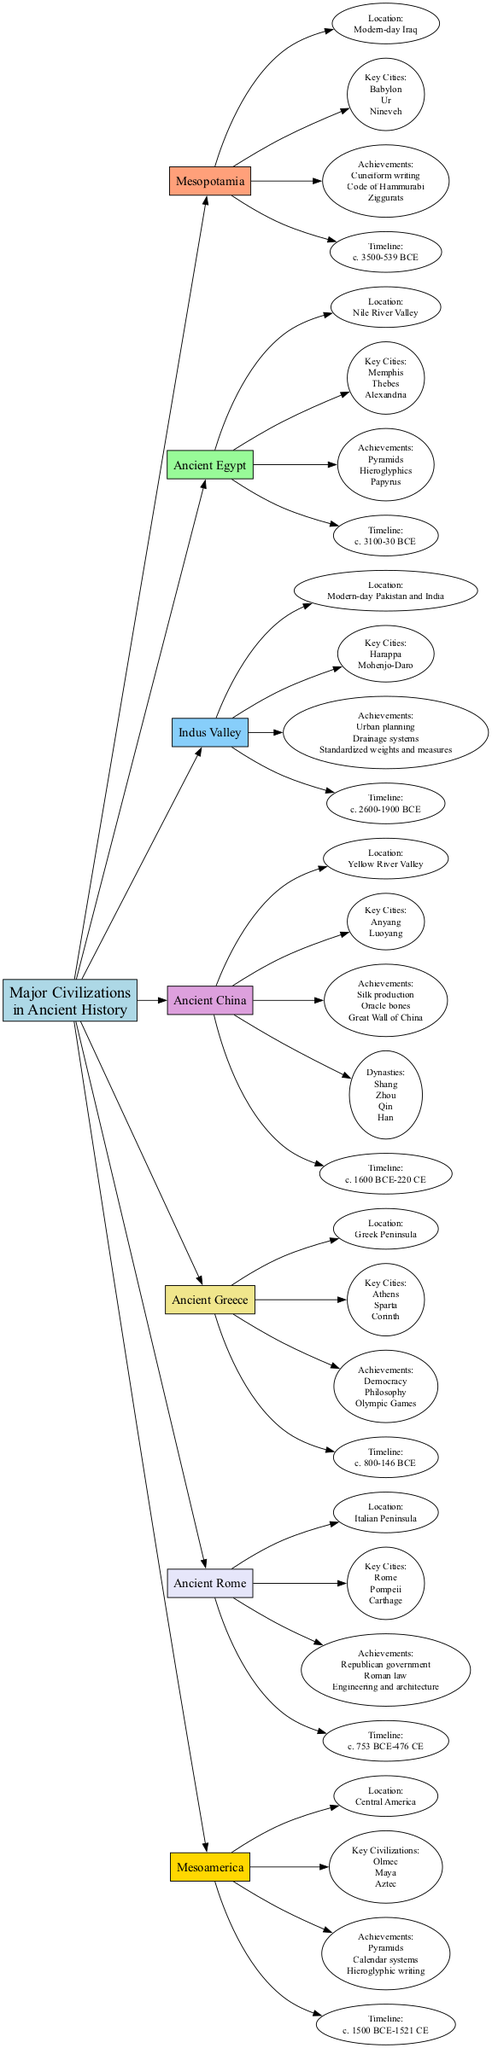What is the location of Ancient Egypt? The diagram shows that Ancient Egypt is located in the Nile River Valley. This is a direct label under the Ancient Egypt node.
Answer: Nile River Valley How many key cities are listed for Mesopotamia? The diagram specifies three key cities under the Mesopotamia node: Babylon, Ur, and Nineveh. Therefore, the count is three.
Answer: 3 Which achievement is associated with Ancient China? Under the Ancient China node, achievements listed include silk production, oracle bones, and the Great Wall of China. Any of these could be the answer, but "silk production" is one as indicated directly under the node.
Answer: Silk production What timeline corresponds to Ancient Rome? The diagram provides the timeline for Ancient Rome as c. 753 BCE-476 CE. This information is clearly detailed under the Ancient Rome node.
Answer: c. 753 BCE-476 CE What civilization is known for urban planning? The Indus Valley civilization is noted for urban planning, this is specified under its own node in the diagram which includes various achievements.
Answer: Indus Valley What are the key civilizations listed in Mesoamerica? Mesoamerica includes three key civilizations as indicated in the diagram: Olmec, Maya, and Aztec. This information is found directly under the Mesoamerica node.
Answer: Olmec, Maya, Aztec Which civilization had the achievement of Cuneiform writing? The achievement of Cuneiform writing belongs to Mesopotamia, as shown in the diagram where this achievement is listed with other key contributions under the Mesopotamia node.
Answer: Mesopotamia What is the primary achievement of Ancient Greece? The primary achievement listed for Ancient Greece is democracy, which is explicitly mentioned as one of its key contributions in the diagram under the Ancient Greece node.
Answer: Democracy Which major river is associated with Ancient China? The diagram indicates that Ancient China is associated with the Yellow River Valley, as noted under the Ancient China node.
Answer: Yellow River Valley 